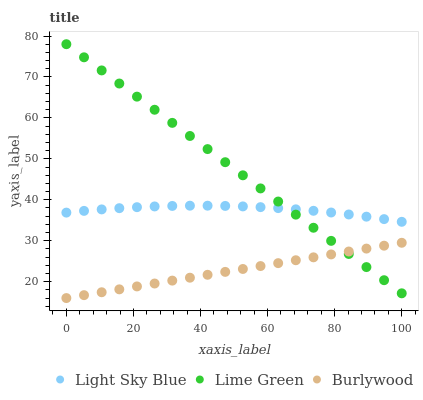Does Burlywood have the minimum area under the curve?
Answer yes or no. Yes. Does Lime Green have the maximum area under the curve?
Answer yes or no. Yes. Does Light Sky Blue have the minimum area under the curve?
Answer yes or no. No. Does Light Sky Blue have the maximum area under the curve?
Answer yes or no. No. Is Burlywood the smoothest?
Answer yes or no. Yes. Is Light Sky Blue the roughest?
Answer yes or no. Yes. Is Lime Green the smoothest?
Answer yes or no. No. Is Lime Green the roughest?
Answer yes or no. No. Does Burlywood have the lowest value?
Answer yes or no. Yes. Does Lime Green have the lowest value?
Answer yes or no. No. Does Lime Green have the highest value?
Answer yes or no. Yes. Does Light Sky Blue have the highest value?
Answer yes or no. No. Is Burlywood less than Light Sky Blue?
Answer yes or no. Yes. Is Light Sky Blue greater than Burlywood?
Answer yes or no. Yes. Does Burlywood intersect Lime Green?
Answer yes or no. Yes. Is Burlywood less than Lime Green?
Answer yes or no. No. Is Burlywood greater than Lime Green?
Answer yes or no. No. Does Burlywood intersect Light Sky Blue?
Answer yes or no. No. 